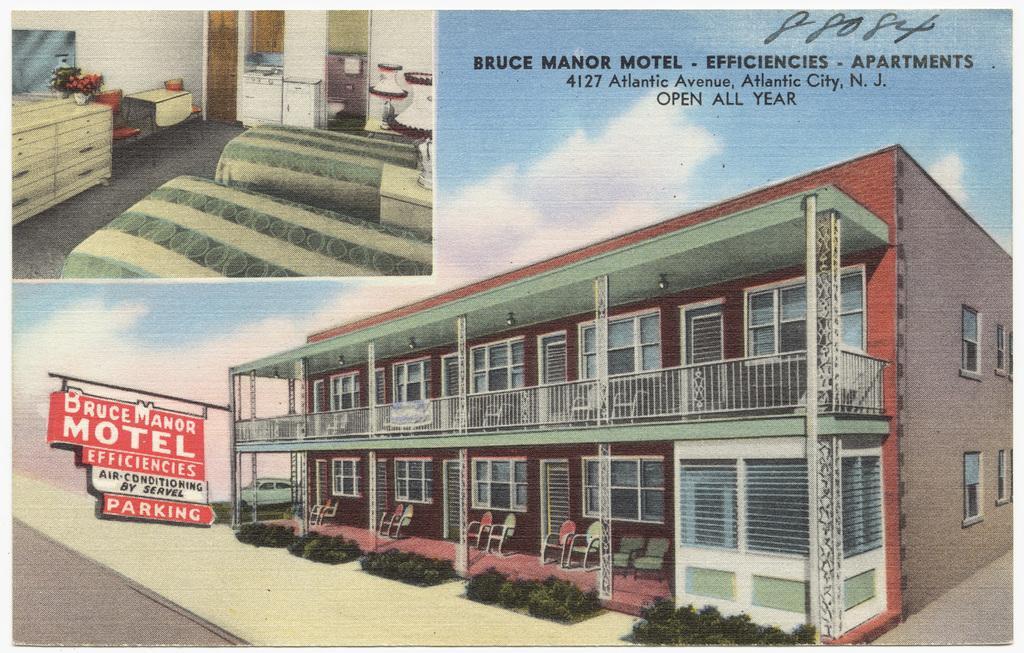Please provide a concise description of this image. It is an edited image,there are total two pictures and in the first image there is a big apartment and in front of the apartment there is a parking board and in the second picture there is an inside picture of the apartment there are two beds,cupboards,refrigerator,washing machine,tables and chairs. It is an advertisement picture. 